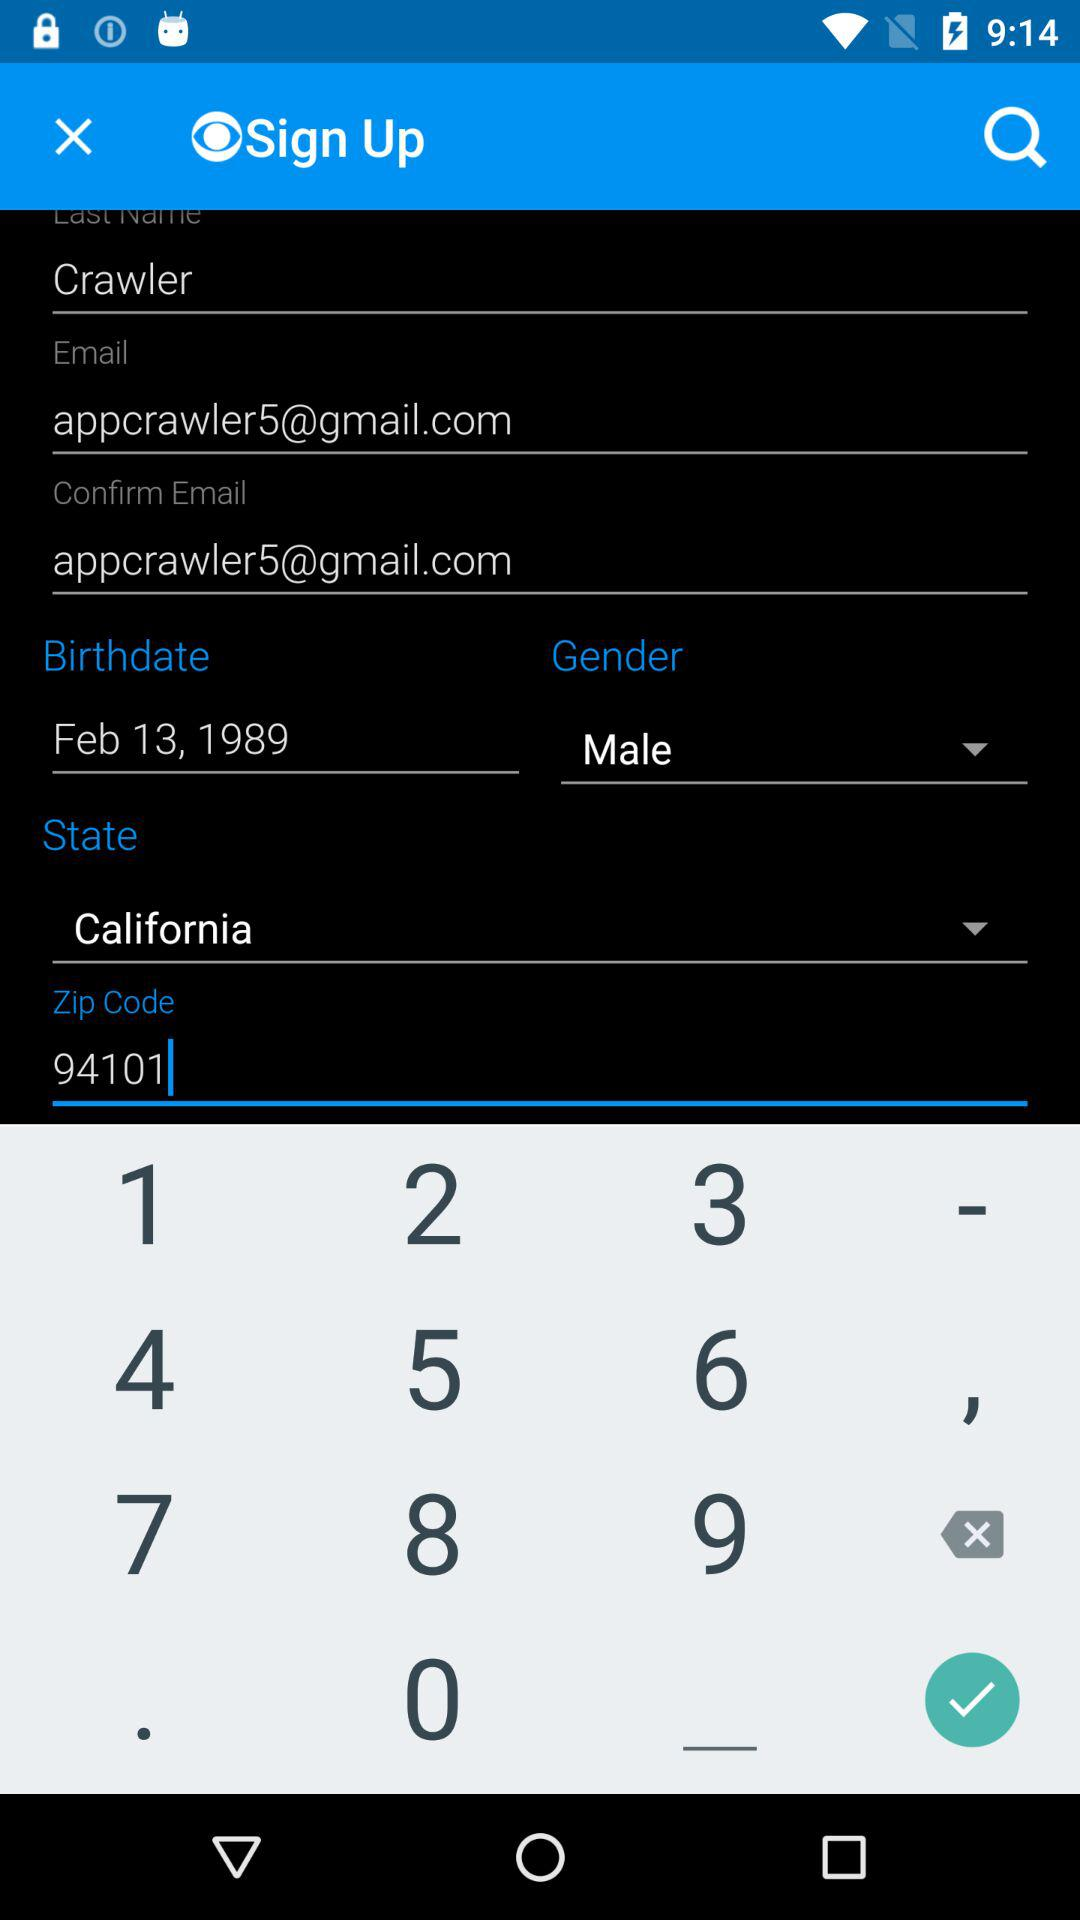What are the different options available to sign in? The options are "Facebook", "Twitter", "Google" and "email". 